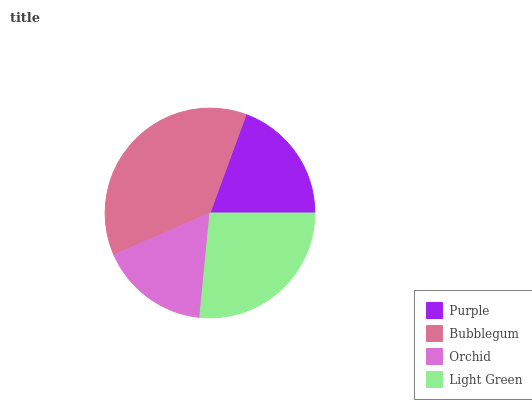Is Orchid the minimum?
Answer yes or no. Yes. Is Bubblegum the maximum?
Answer yes or no. Yes. Is Bubblegum the minimum?
Answer yes or no. No. Is Orchid the maximum?
Answer yes or no. No. Is Bubblegum greater than Orchid?
Answer yes or no. Yes. Is Orchid less than Bubblegum?
Answer yes or no. Yes. Is Orchid greater than Bubblegum?
Answer yes or no. No. Is Bubblegum less than Orchid?
Answer yes or no. No. Is Light Green the high median?
Answer yes or no. Yes. Is Purple the low median?
Answer yes or no. Yes. Is Bubblegum the high median?
Answer yes or no. No. Is Light Green the low median?
Answer yes or no. No. 